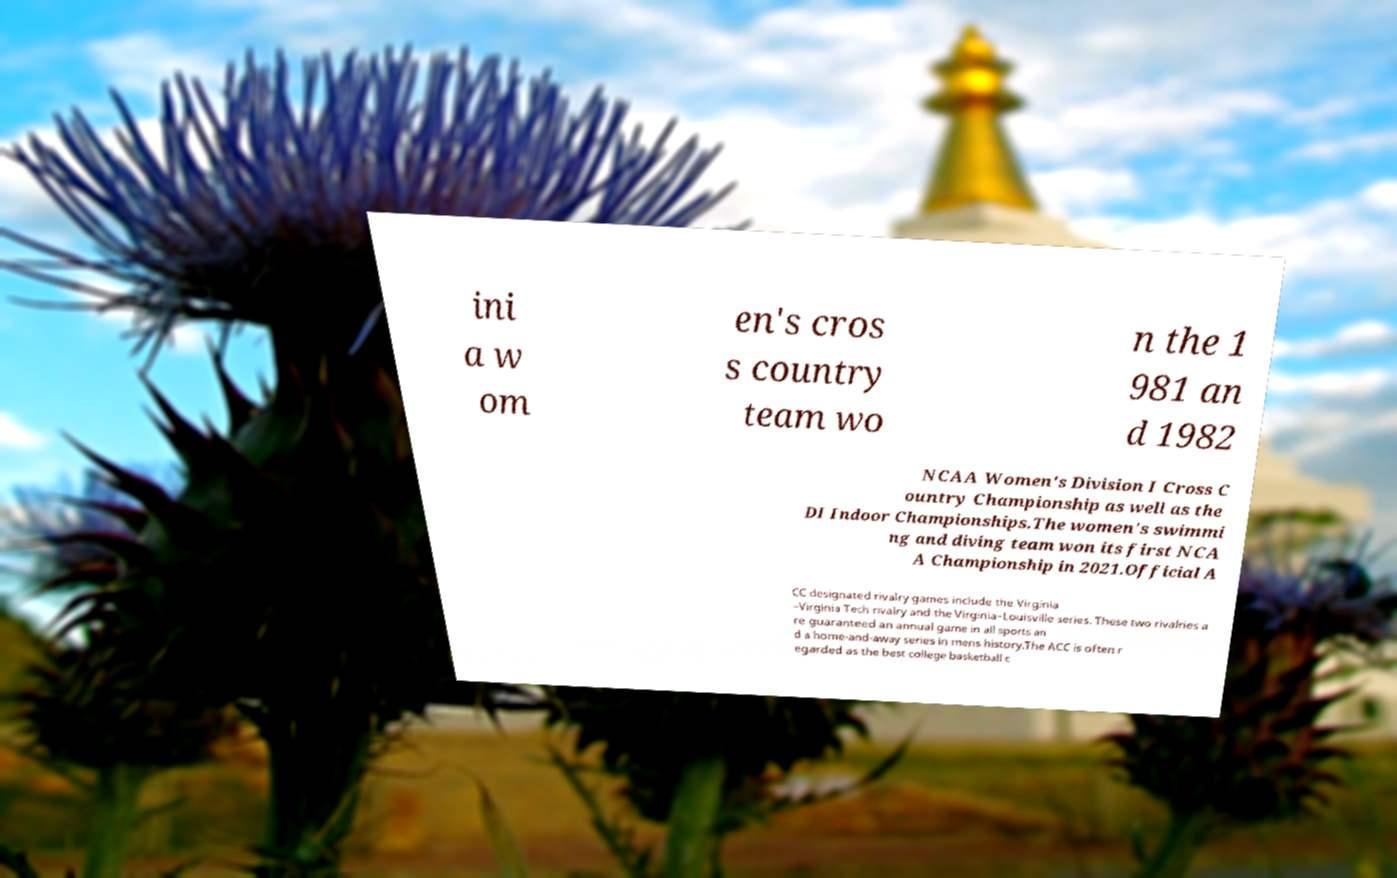I need the written content from this picture converted into text. Can you do that? ini a w om en's cros s country team wo n the 1 981 an d 1982 NCAA Women's Division I Cross C ountry Championship as well as the DI Indoor Championships.The women's swimmi ng and diving team won its first NCA A Championship in 2021.Official A CC designated rivalry games include the Virginia –Virginia Tech rivalry and the Virginia–Louisville series. These two rivalries a re guaranteed an annual game in all sports an d a home-and-away series in mens history.The ACC is often r egarded as the best college basketball c 